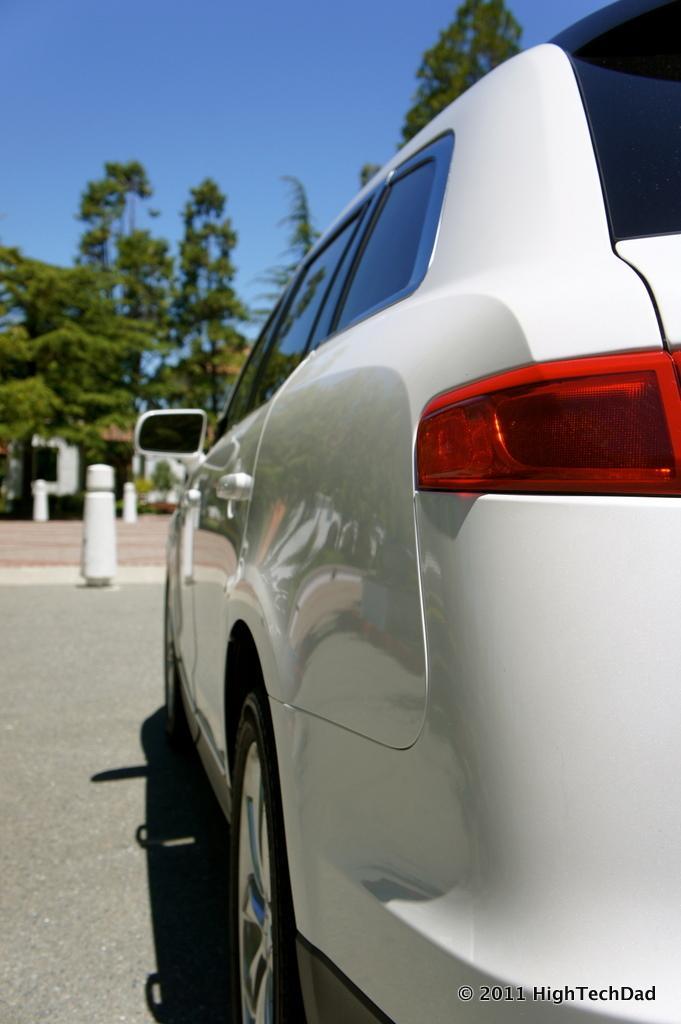How would you summarize this image in a sentence or two? In this image we can see car. In the back there are small poles. Also there are trees. In the background there is sky. In the right bottom corner there is watermark. 